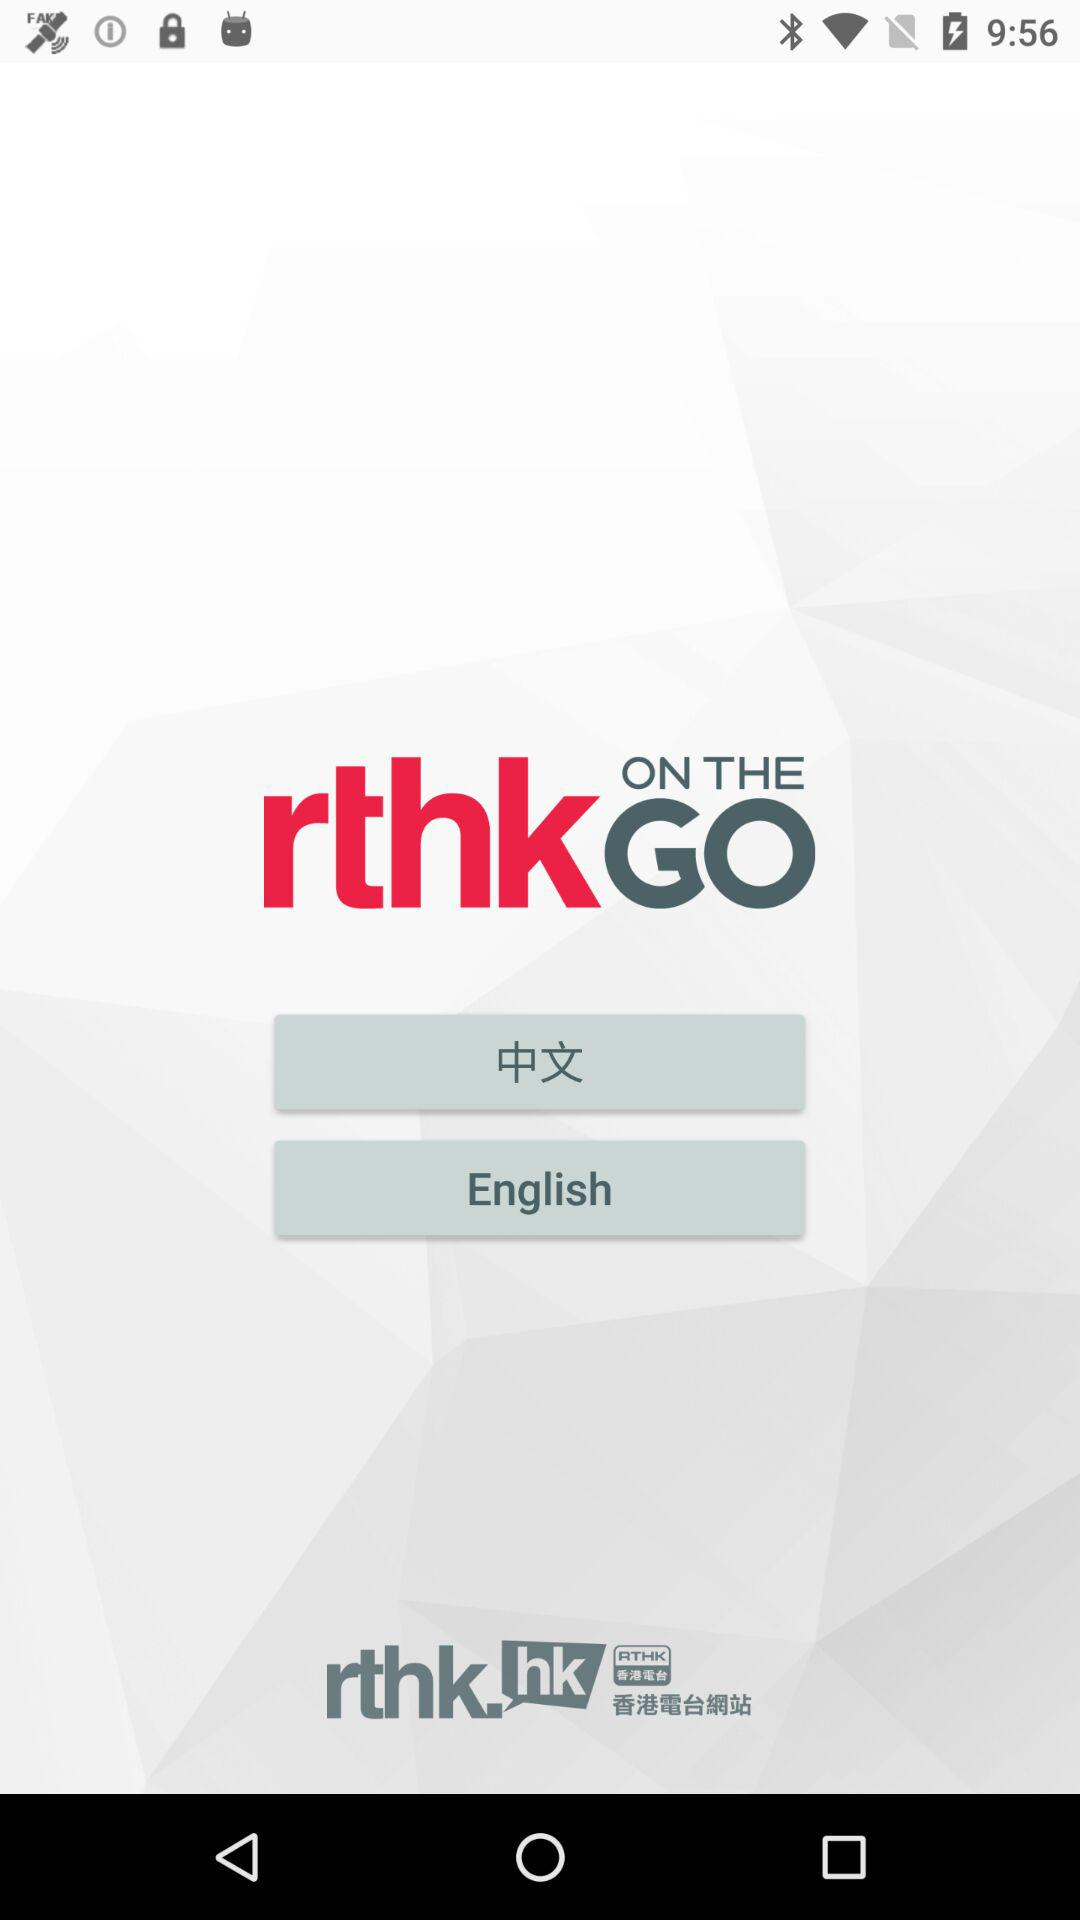How many languages are available on the screen?
Answer the question using a single word or phrase. 2 